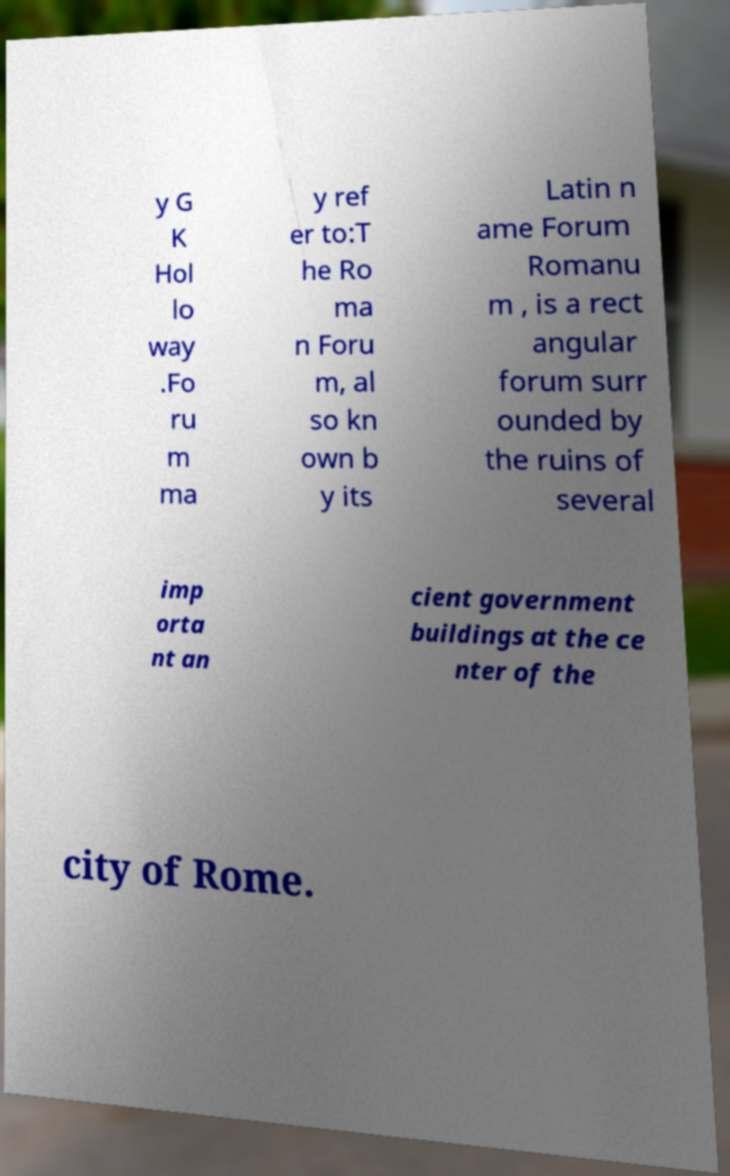I need the written content from this picture converted into text. Can you do that? y G K Hol lo way .Fo ru m ma y ref er to:T he Ro ma n Foru m, al so kn own b y its Latin n ame Forum Romanu m , is a rect angular forum surr ounded by the ruins of several imp orta nt an cient government buildings at the ce nter of the city of Rome. 